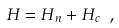Convert formula to latex. <formula><loc_0><loc_0><loc_500><loc_500>H = H _ { n } + H _ { c } \ ,</formula> 